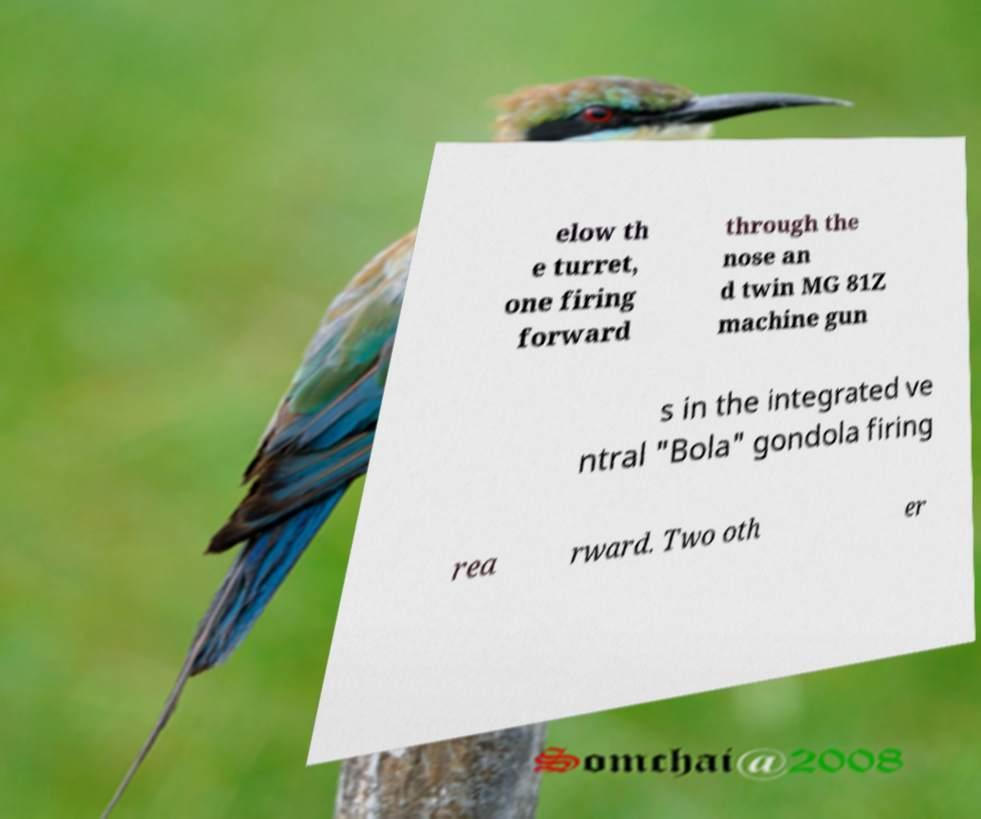Could you assist in decoding the text presented in this image and type it out clearly? elow th e turret, one firing forward through the nose an d twin MG 81Z machine gun s in the integrated ve ntral "Bola" gondola firing rea rward. Two oth er 